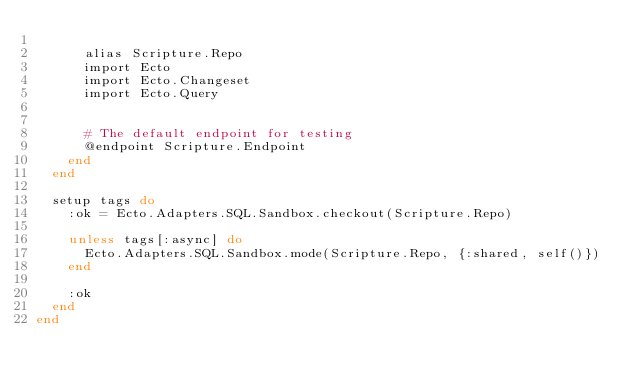<code> <loc_0><loc_0><loc_500><loc_500><_Elixir_>
      alias Scripture.Repo
      import Ecto
      import Ecto.Changeset
      import Ecto.Query


      # The default endpoint for testing
      @endpoint Scripture.Endpoint
    end
  end

  setup tags do
    :ok = Ecto.Adapters.SQL.Sandbox.checkout(Scripture.Repo)

    unless tags[:async] do
      Ecto.Adapters.SQL.Sandbox.mode(Scripture.Repo, {:shared, self()})
    end

    :ok
  end
end
</code> 